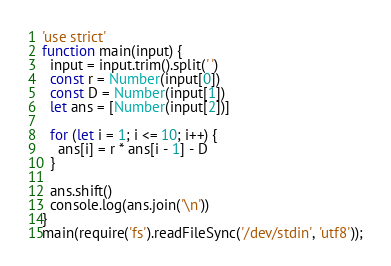Convert code to text. <code><loc_0><loc_0><loc_500><loc_500><_JavaScript_>'use strict'
function main(input) {
  input = input.trim().split(' ')
  const r = Number(input[0])
  const D = Number(input[1])
  let ans = [Number(input[2])]

  for (let i = 1; i <= 10; i++) {
    ans[i] = r * ans[i - 1] - D
  }

  ans.shift()
  console.log(ans.join('\n'))
}
main(require('fs').readFileSync('/dev/stdin', 'utf8'));
</code> 